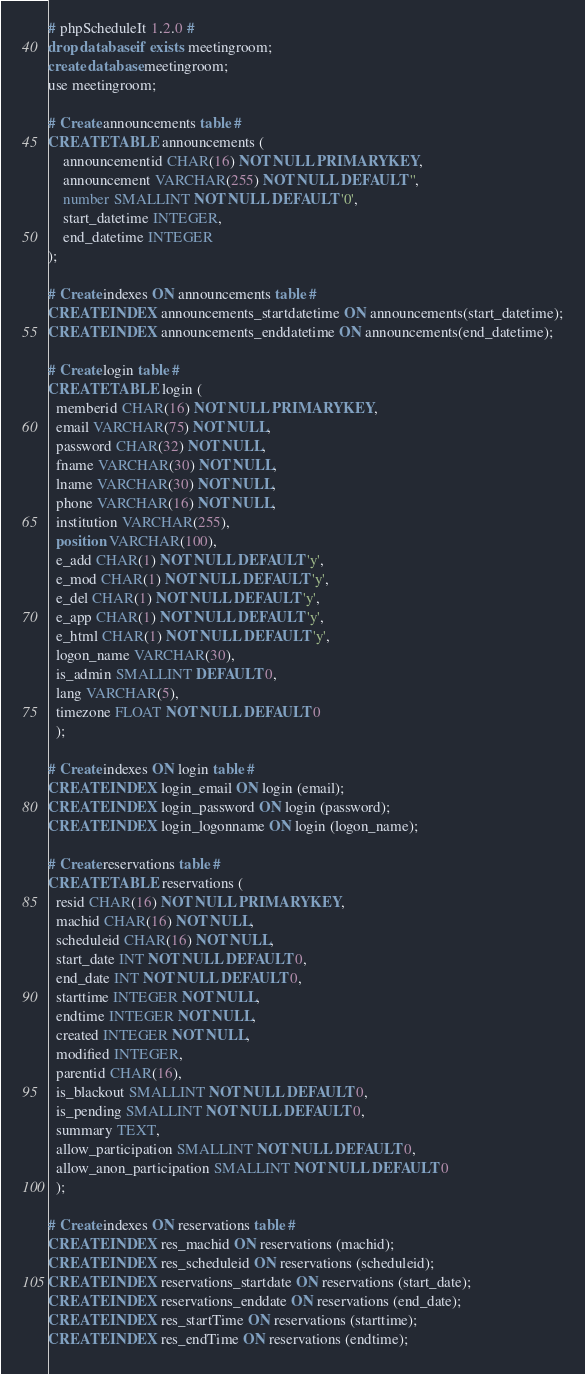Convert code to text. <code><loc_0><loc_0><loc_500><loc_500><_SQL_># phpScheduleIt 1.2.0 #
drop database if exists meetingroom;
create database meetingroom;
use meetingroom;

# Create announcements table #
CREATE TABLE announcements (
    announcementid CHAR(16) NOT NULL PRIMARY KEY,
    announcement VARCHAR(255) NOT NULL DEFAULT '',
    number SMALLINT NOT NULL DEFAULT '0',
    start_datetime INTEGER,
    end_datetime INTEGER
);

# Create indexes ON announcements table #
CREATE INDEX announcements_startdatetime ON announcements(start_datetime);
CREATE INDEX announcements_enddatetime ON announcements(end_datetime);

# Create login table #
CREATE TABLE login (
  memberid CHAR(16) NOT NULL PRIMARY KEY,
  email VARCHAR(75) NOT NULL,
  password CHAR(32) NOT NULL,
  fname VARCHAR(30) NOT NULL,
  lname VARCHAR(30) NOT NULL,
  phone VARCHAR(16) NOT NULL,
  institution VARCHAR(255),
  position VARCHAR(100),
  e_add CHAR(1) NOT NULL DEFAULT 'y',
  e_mod CHAR(1) NOT NULL DEFAULT 'y',
  e_del CHAR(1) NOT NULL DEFAULT 'y',
  e_app CHAR(1) NOT NULL DEFAULT 'y',
  e_html CHAR(1) NOT NULL DEFAULT 'y',
  logon_name VARCHAR(30),
  is_admin SMALLINT DEFAULT 0,
  lang VARCHAR(5),
  timezone FLOAT NOT NULL DEFAULT 0
  );

# Create indexes ON login table #
CREATE INDEX login_email ON login (email);
CREATE INDEX login_password ON login (password);
CREATE INDEX login_logonname ON login (logon_name);

# Create reservations table #  
CREATE TABLE reservations (
  resid CHAR(16) NOT NULL PRIMARY KEY,
  machid CHAR(16) NOT NULL,
  scheduleid CHAR(16) NOT NULL,
  start_date INT NOT NULL DEFAULT 0,
  end_date INT NOT NULL DEFAULT 0,
  starttime INTEGER NOT NULL,
  endtime INTEGER NOT NULL,
  created INTEGER NOT NULL,
  modified INTEGER,
  parentid CHAR(16),
  is_blackout SMALLINT NOT NULL DEFAULT 0,
  is_pending SMALLINT NOT NULL DEFAULT 0,
  summary TEXT,
  allow_participation SMALLINT NOT NULL DEFAULT 0,
  allow_anon_participation SMALLINT NOT NULL DEFAULT 0
  );

# Create indexes ON reservations table #
CREATE INDEX res_machid ON reservations (machid);
CREATE INDEX res_scheduleid ON reservations (scheduleid);
CREATE INDEX reservations_startdate ON reservations (start_date);
CREATE INDEX reservations_enddate ON reservations (end_date);
CREATE INDEX res_startTime ON reservations (starttime);
CREATE INDEX res_endTime ON reservations (endtime);</code> 